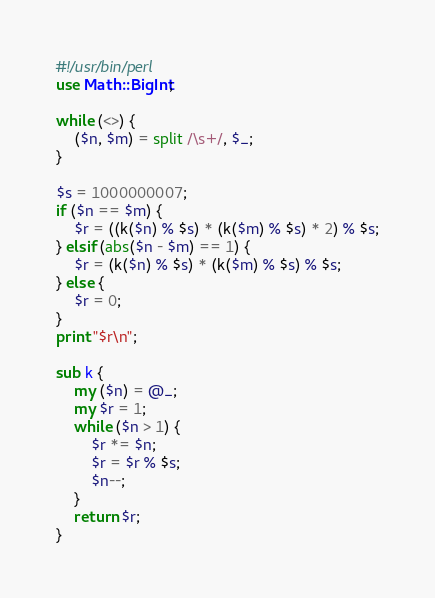<code> <loc_0><loc_0><loc_500><loc_500><_Perl_>#!/usr/bin/perl
use Math::BigInt;

while (<>) {
    ($n, $m) = split /\s+/, $_;
}

$s = 1000000007;
if ($n == $m) {
    $r = ((k($n) % $s) * (k($m) % $s) * 2) % $s;
} elsif (abs($n - $m) == 1) {
    $r = (k($n) % $s) * (k($m) % $s) % $s;
} else {
    $r = 0;
}
print "$r\n";

sub k {
    my ($n) = @_;
    my $r = 1;
    while ($n > 1) {
        $r *= $n;
        $r = $r % $s;
        $n--;
    }
    return $r;
}
</code> 